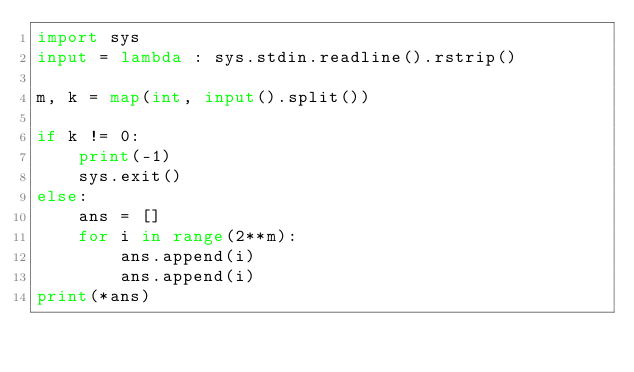Convert code to text. <code><loc_0><loc_0><loc_500><loc_500><_Python_>import sys
input = lambda : sys.stdin.readline().rstrip()

m, k = map(int, input().split())

if k != 0:
    print(-1)
    sys.exit()
else:
    ans = []
    for i in range(2**m):
        ans.append(i)
        ans.append(i)
print(*ans)</code> 